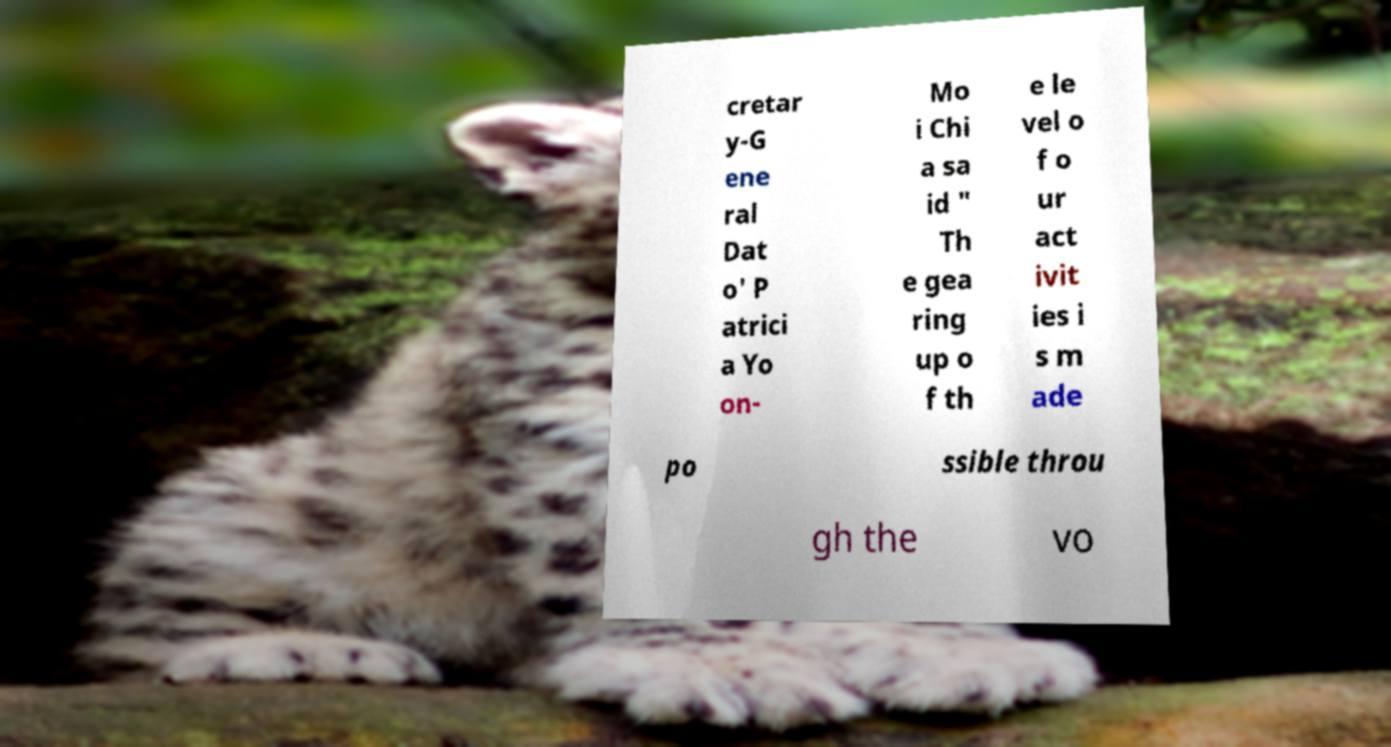There's text embedded in this image that I need extracted. Can you transcribe it verbatim? cretar y-G ene ral Dat o' P atrici a Yo on- Mo i Chi a sa id " Th e gea ring up o f th e le vel o f o ur act ivit ies i s m ade po ssible throu gh the vo 